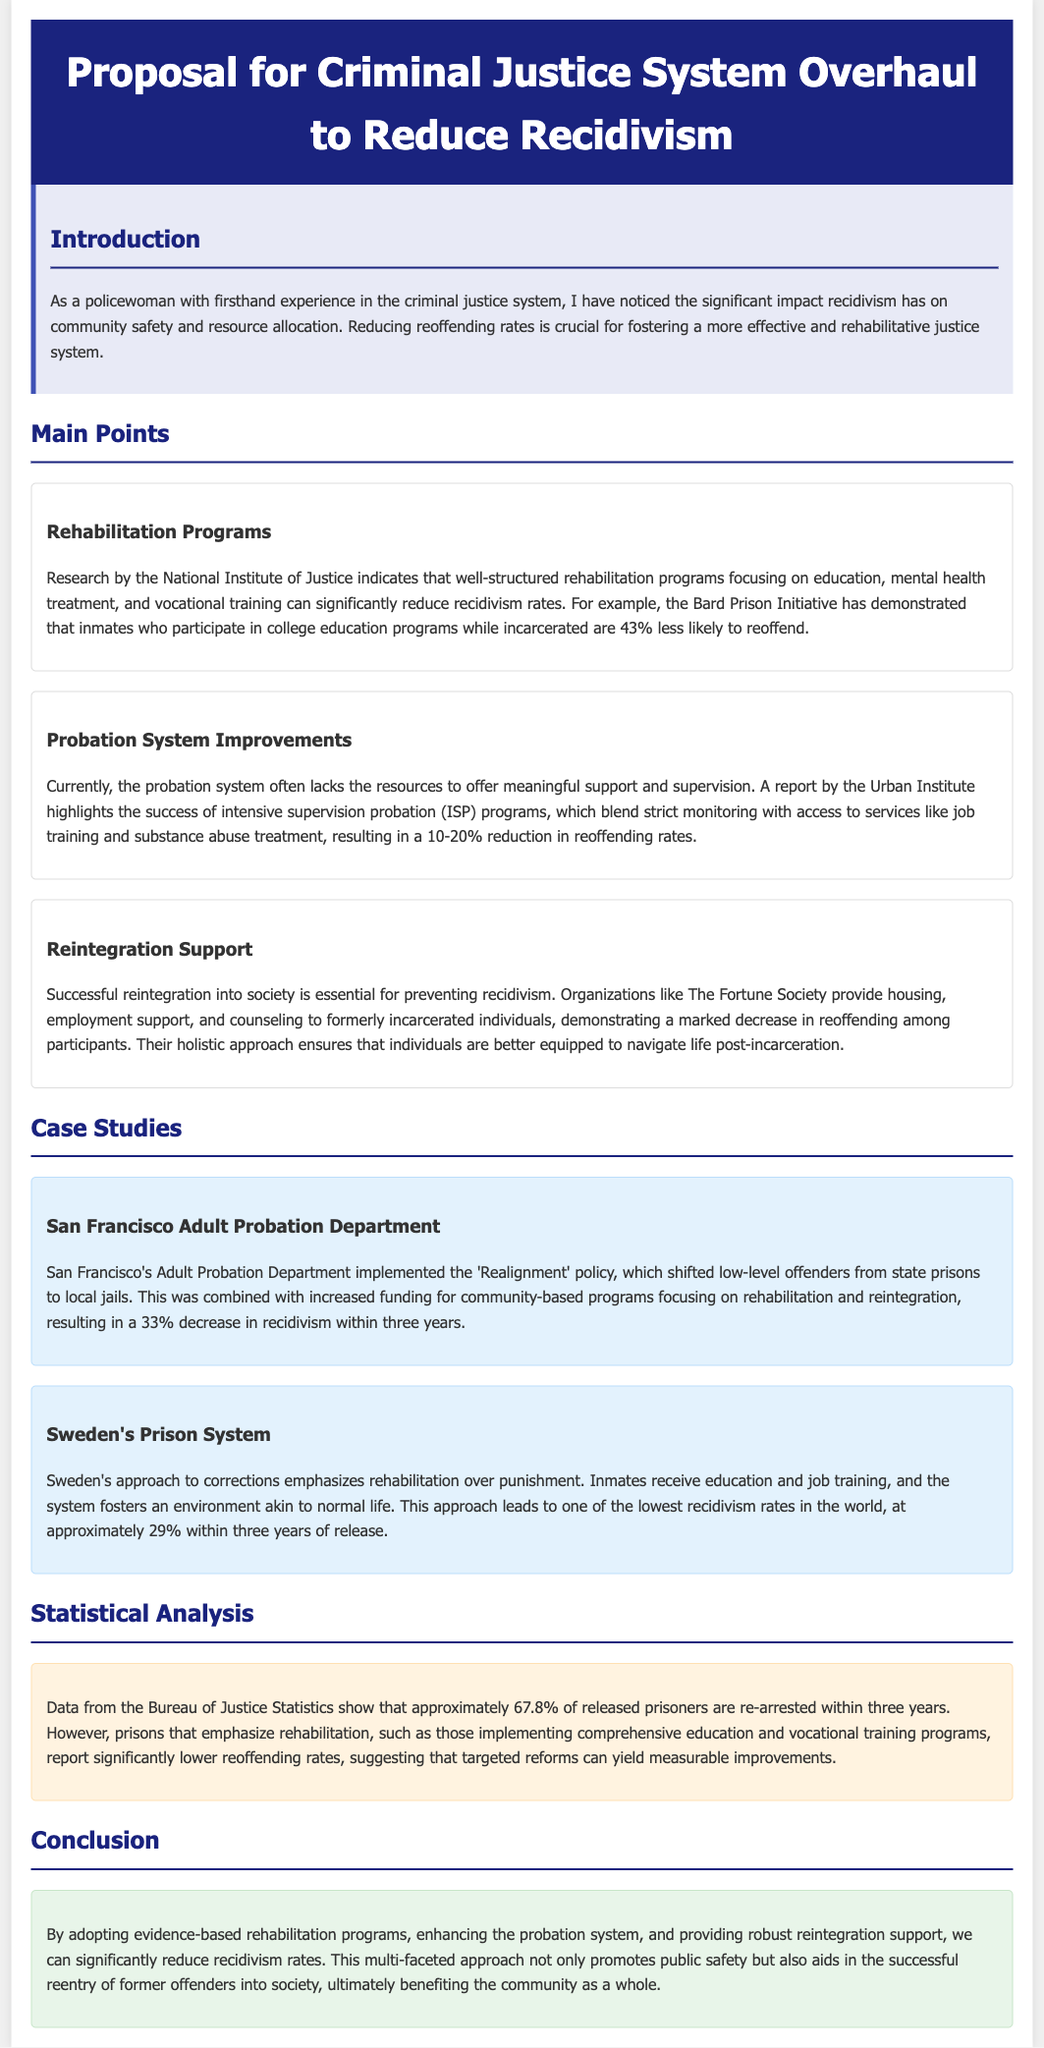What is the main purpose of the proposal? The main purpose is to explore reforms aimed at reducing reoffending rates.
Answer: reducing reoffending rates Which organization conducted research on rehabilitation programs? The National Institute of Justice conducted research on rehabilitation programs.
Answer: National Institute of Justice What is the percentage drop in recidivism rates demonstrated by the Bard Prison Initiative? Inmates who participate in college education programs are 43% less likely to reoffend.
Answer: 43% Which policy did the San Francisco Adult Probation Department implement? The 'Realignment' policy was implemented by the San Francisco Adult Probation Department.
Answer: Realignment How many former offenders successfully reintegrated with support from The Fortune Society? The proposal mentions "a marked decrease" without specifying a number for participants.
Answer: Not specified What is the reported re-arrest rate within three years of released prisoners? Approximately 67.8% of released prisoners are re-arrested within three years.
Answer: 67.8% What approach does Sweden's prison system emphasize? Sweden emphasizes rehabilitation over punishment in its prison system.
Answer: rehabilitation What are the two main components blended in intensive supervision probation? Intensive supervision probation blends strict monitoring with access to services.
Answer: strict monitoring and access to services What is the conclusion of the proposal? The conclusion emphasizes adopting evidence-based rehabilitation programs, enhancing probation, and reintegration support to reduce recidivism.
Answer: reducing recidivism 